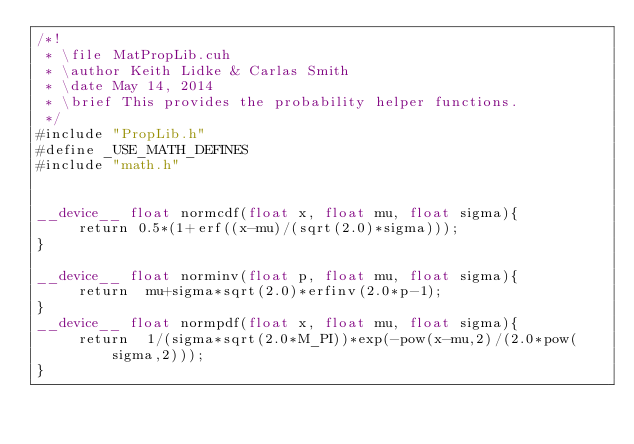Convert code to text. <code><loc_0><loc_0><loc_500><loc_500><_Cuda_>/*!
 * \file MatPropLib.cuh
 * \author Keith Lidke & Carlas Smith
 * \date May 14, 2014
 * \brief This provides the probability helper functions.
 */
#include "PropLib.h"
#define _USE_MATH_DEFINES
#include "math.h"


__device__ float normcdf(float x, float mu, float sigma){
     return 0.5*(1+erf((x-mu)/(sqrt(2.0)*sigma)));   
}

__device__ float norminv(float p, float mu, float sigma){
     return  mu+sigma*sqrt(2.0)*erfinv(2.0*p-1);
}
__device__ float normpdf(float x, float mu, float sigma){
     return  1/(sigma*sqrt(2.0*M_PI))*exp(-pow(x-mu,2)/(2.0*pow(sigma,2)));
}

    </code> 